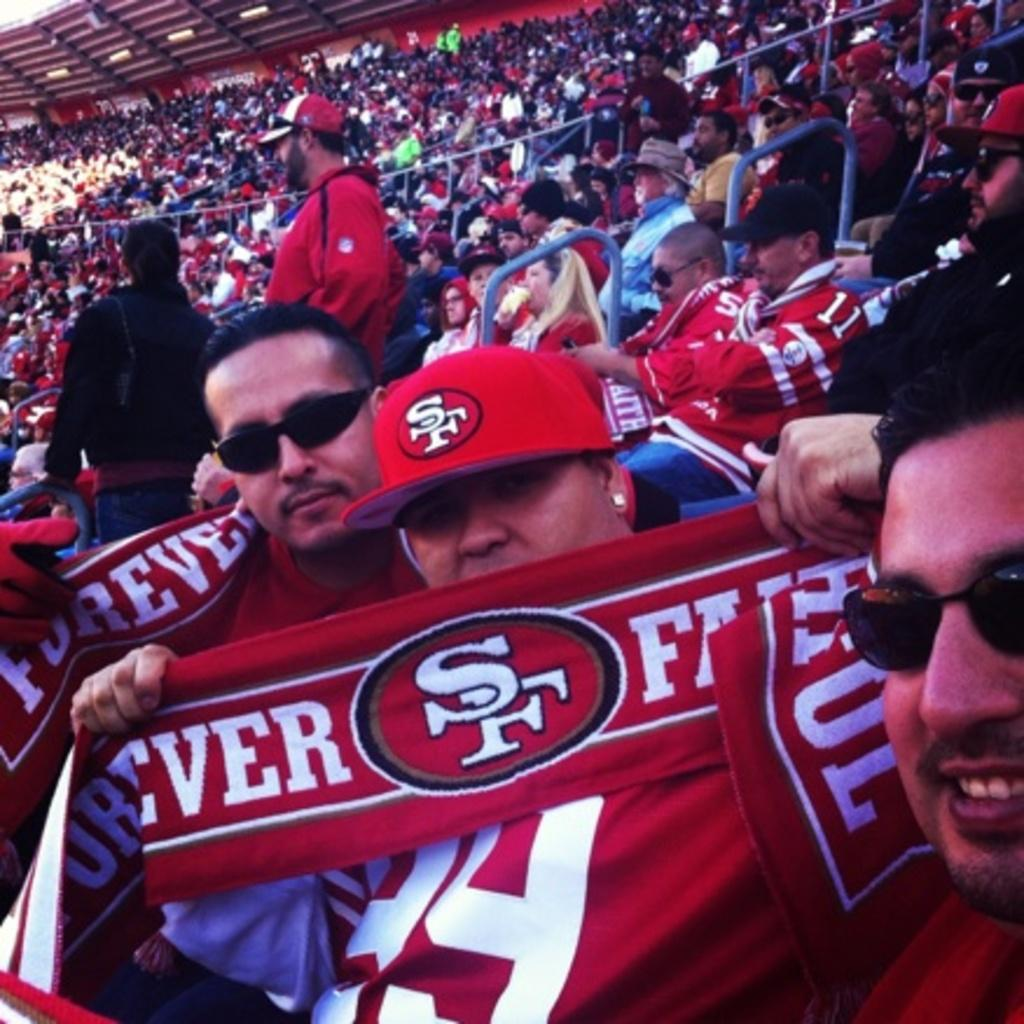<image>
Create a compact narrative representing the image presented. San Francisco 49ers fans holding red towels sit in the stands of the stadium. 